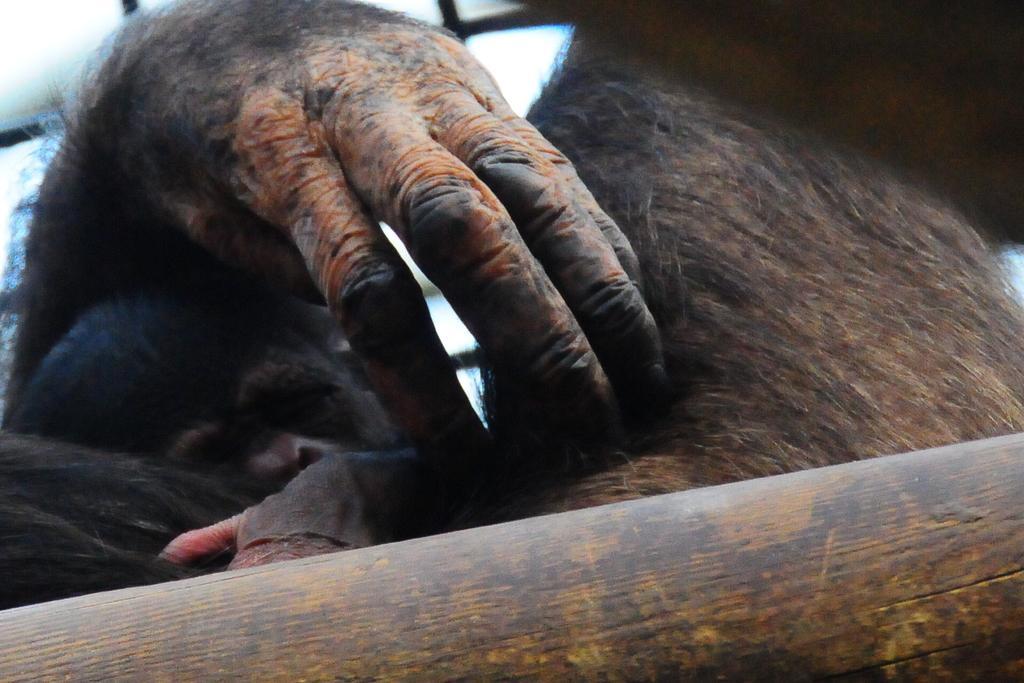Describe this image in one or two sentences. In this picture we can see two animals and we can see wooden object. 